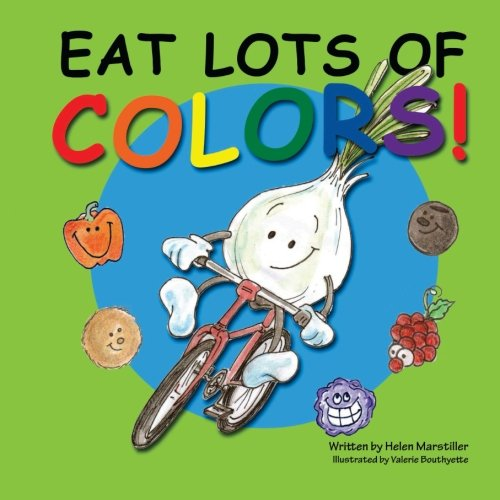Can you describe the main visual themes depicted on the cover of this book? The cover features vibrant and colorful illustrations of fruits and vegetables, along with a central character, a smiling garlic bulb riding a bicycle. This playful imagery emphasizes the book's focus on healthy eating and nutrition in a way that's appealing to children. 